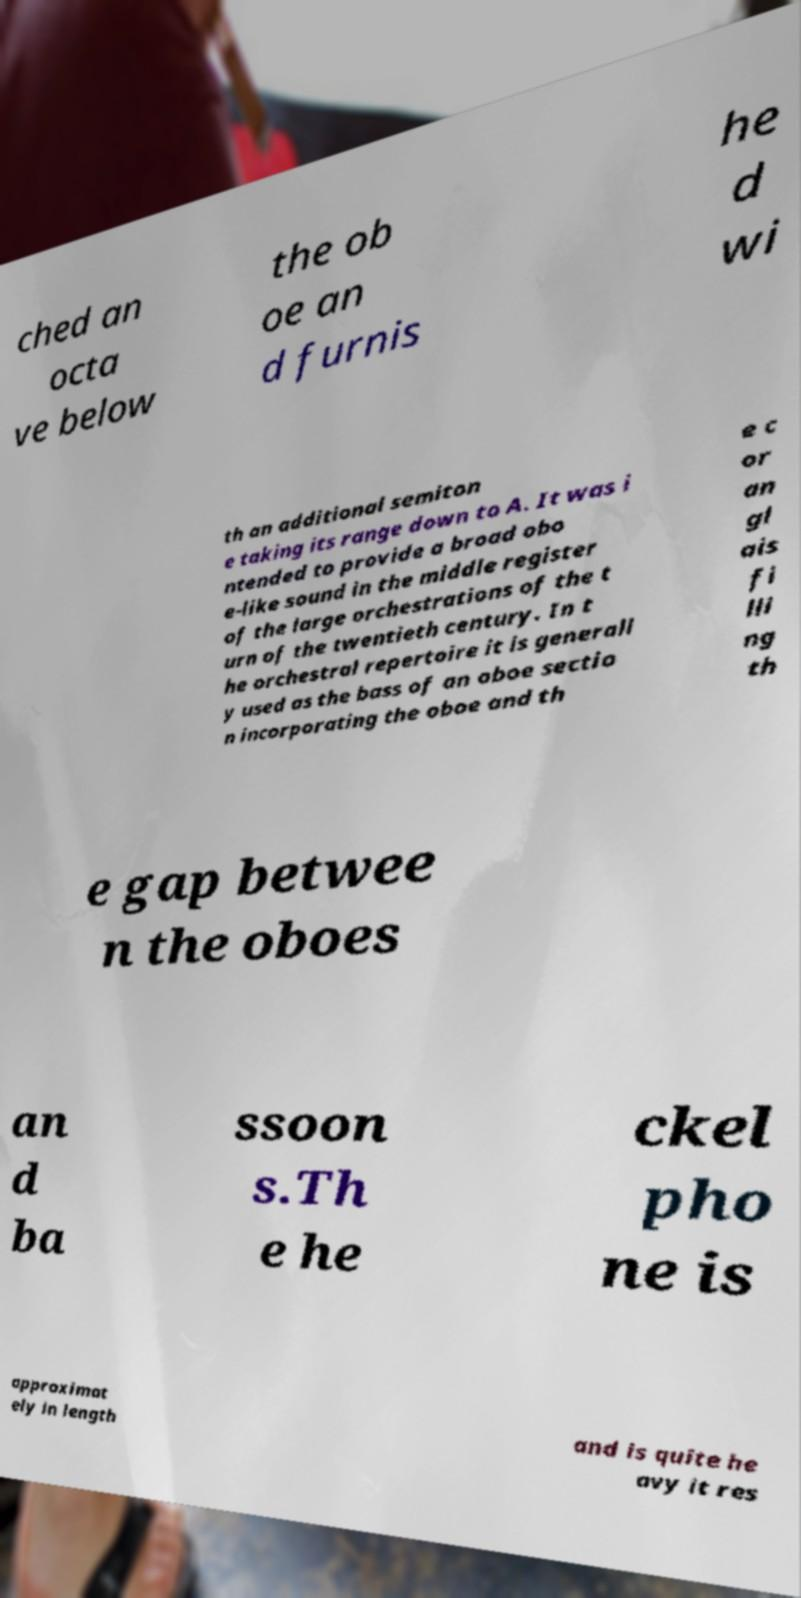There's text embedded in this image that I need extracted. Can you transcribe it verbatim? ched an octa ve below the ob oe an d furnis he d wi th an additional semiton e taking its range down to A. It was i ntended to provide a broad obo e-like sound in the middle register of the large orchestrations of the t urn of the twentieth century. In t he orchestral repertoire it is generall y used as the bass of an oboe sectio n incorporating the oboe and th e c or an gl ais fi lli ng th e gap betwee n the oboes an d ba ssoon s.Th e he ckel pho ne is approximat ely in length and is quite he avy it res 